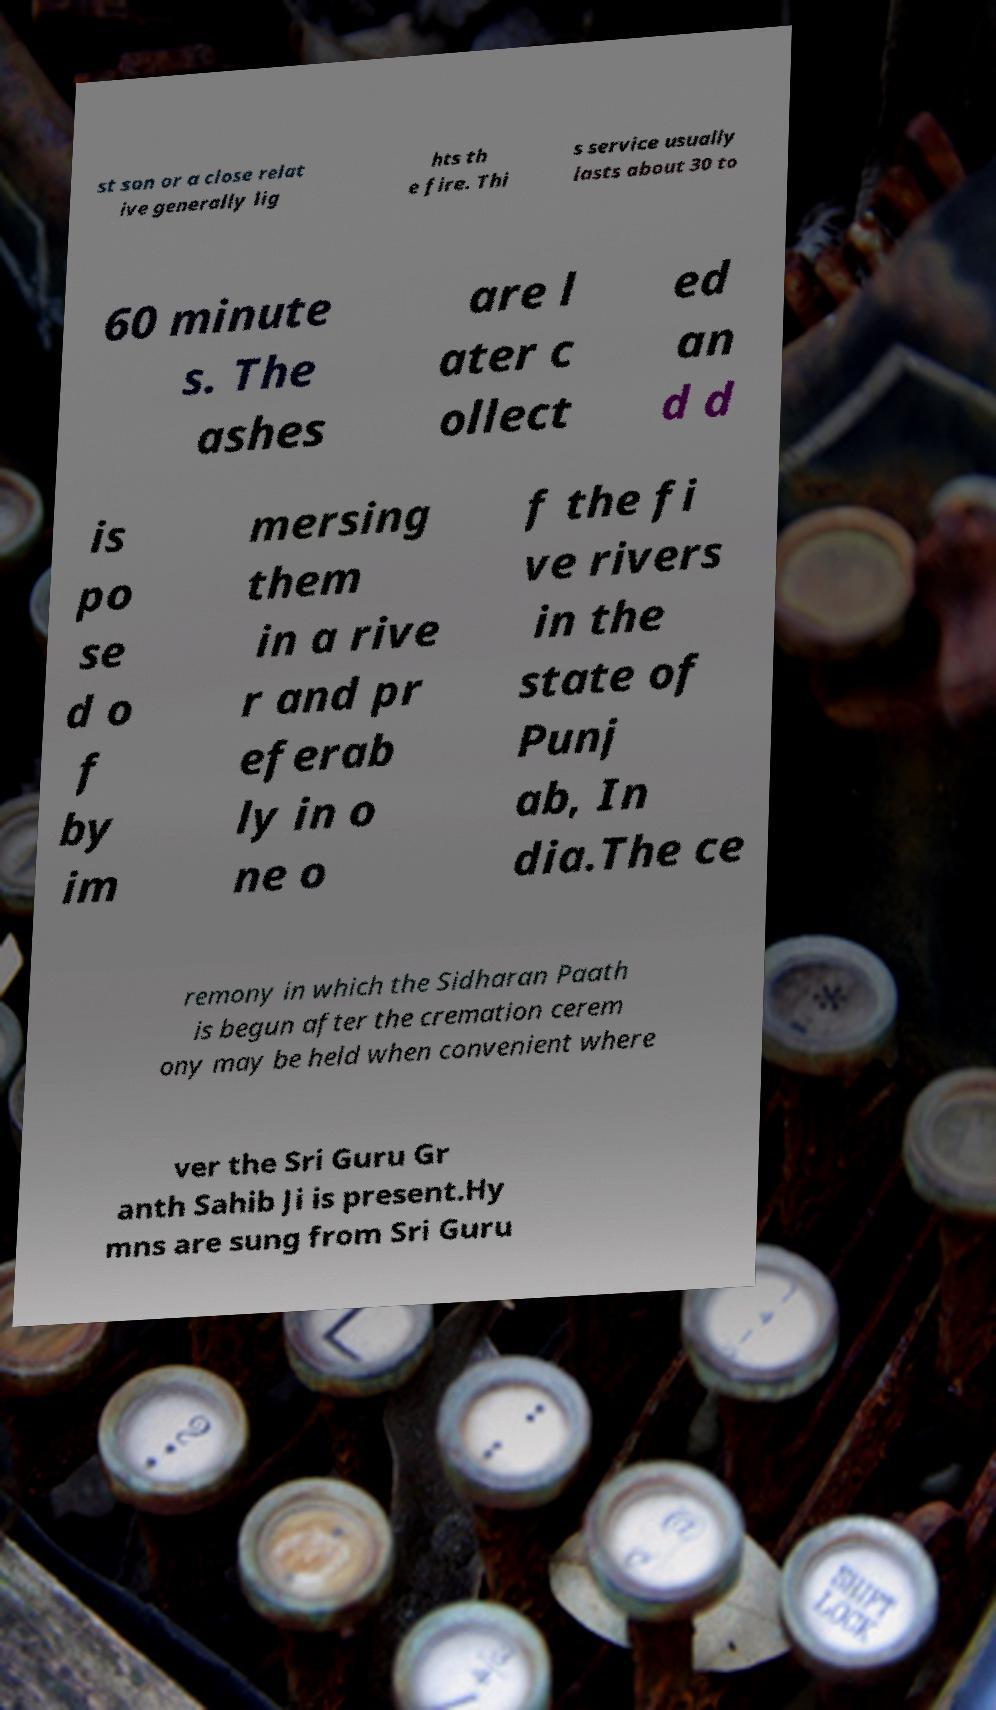For documentation purposes, I need the text within this image transcribed. Could you provide that? st son or a close relat ive generally lig hts th e fire. Thi s service usually lasts about 30 to 60 minute s. The ashes are l ater c ollect ed an d d is po se d o f by im mersing them in a rive r and pr eferab ly in o ne o f the fi ve rivers in the state of Punj ab, In dia.The ce remony in which the Sidharan Paath is begun after the cremation cerem ony may be held when convenient where ver the Sri Guru Gr anth Sahib Ji is present.Hy mns are sung from Sri Guru 